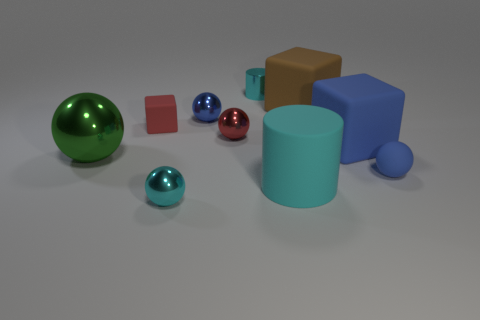Subtract all red spheres. How many spheres are left? 4 Subtract 1 spheres. How many spheres are left? 4 Subtract all matte spheres. How many spheres are left? 4 Subtract all gray balls. Subtract all blue cubes. How many balls are left? 5 Subtract all cylinders. How many objects are left? 8 Subtract 0 blue cylinders. How many objects are left? 10 Subtract all large rubber things. Subtract all tiny blue rubber blocks. How many objects are left? 7 Add 3 tiny blue objects. How many tiny blue objects are left? 5 Add 5 big metallic objects. How many big metallic objects exist? 6 